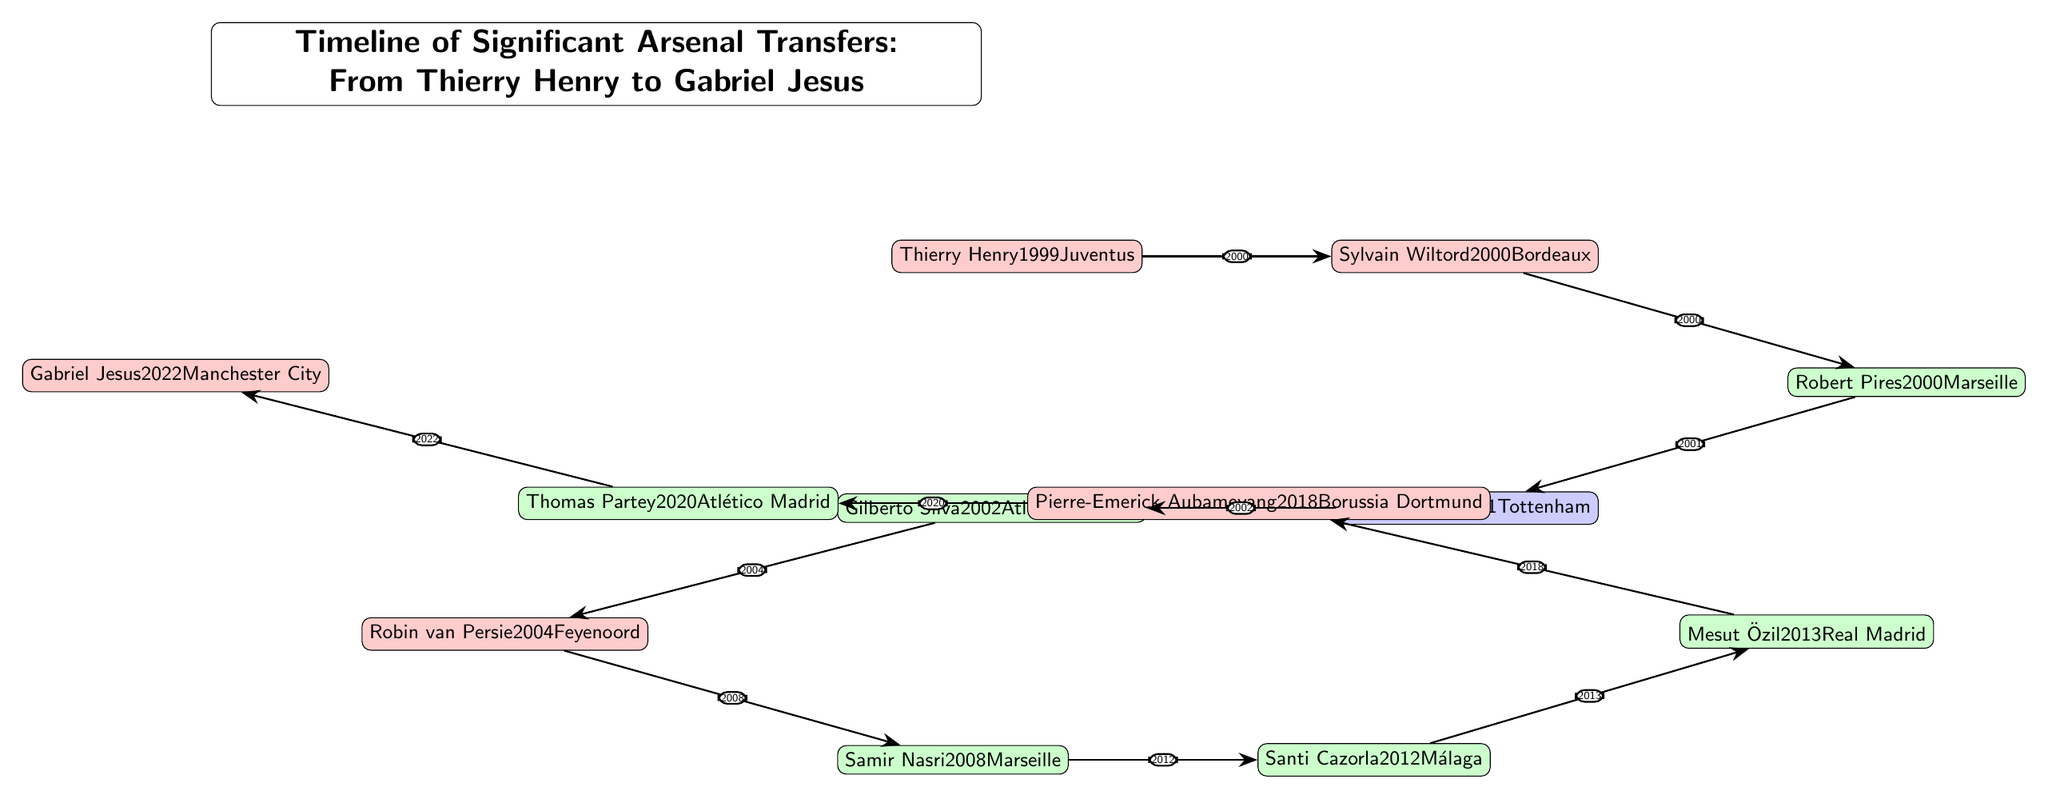What year did Arsenal sign Thierry Henry? The diagram indicates that Thierry Henry was signed in the year listed directly below his name, which is clearly marked as 1999.
Answer: 1999 Which player was transferred from Borussia Dortmund? Referring to the diagram, the player associated with Borussia Dortmund is Pierre-Emerick Aubameyang, whose name is positioned directly above the label of his former club.
Answer: Pierre-Emerick Aubameyang How many midfielders are listed in this timeline? Reviewing the diagram, the players categorized as midfielders are Robert Pires, Gilberto Silva, Samir Nasri, Santi Cazorla, Mesut Özil, and Thomas Partey, amounting to a total of six midfielders.
Answer: Six What transfer occurred immediately after Santi Cazorla? By examining the connections, Santi Cazorla is followed by Mesut Özil in the timeline, which is shown by the directional arrow leading from Cazorla to Özil.
Answer: Mesut Özil What was the last transfer shown in the timeline? The final player in the sequence is Gabriel Jesus, who is positioned at the end of the timeline, indicating he was the last significant transfer listed.
Answer: Gabriel Jesus Which two transfers occurred in 2000? Checking the year labels associated with the players, both Thierry Henry and Sylvain Wiltord were transferred in 2000, shown by the edges connecting them with the year noted on the corresponding lines.
Answer: Thierry Henry and Sylvain Wiltord 